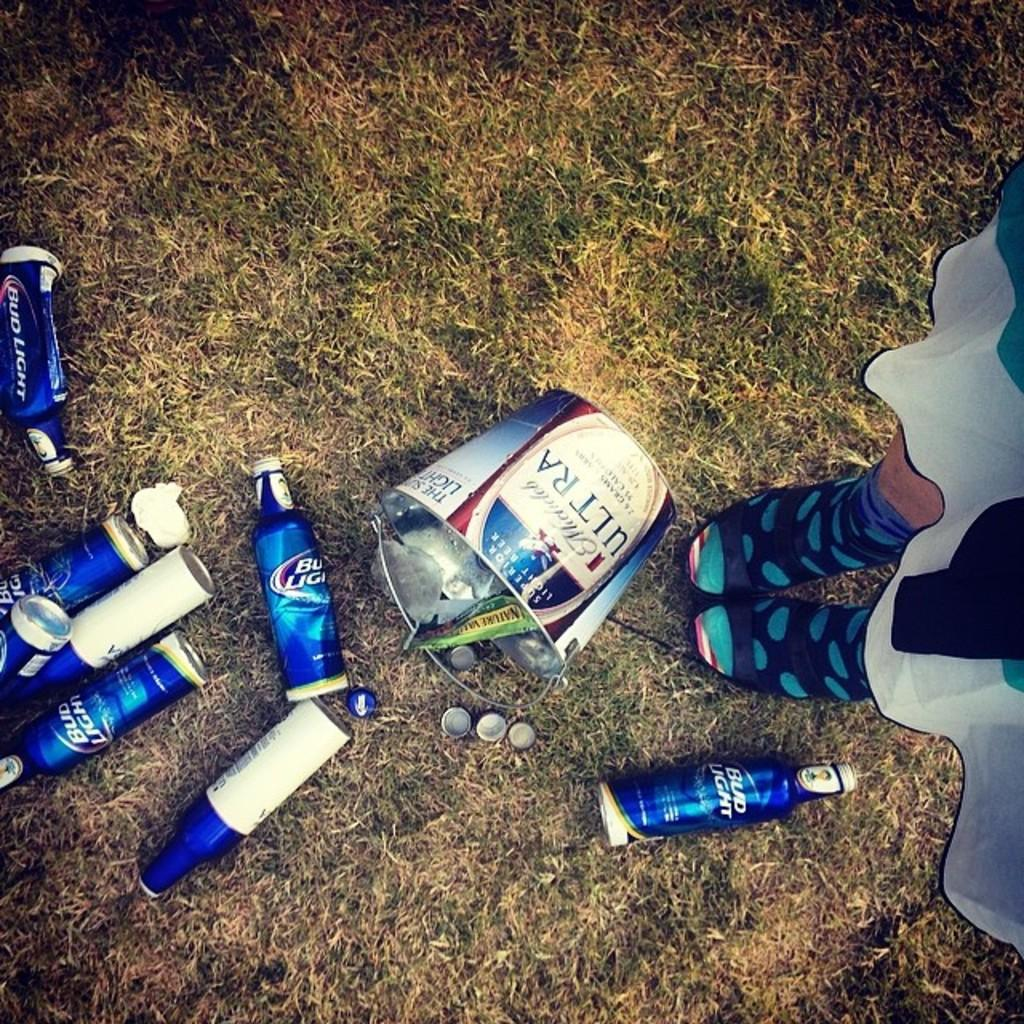<image>
Relay a brief, clear account of the picture shown. A spiled beer bucket with empty bud light bottles around it. 